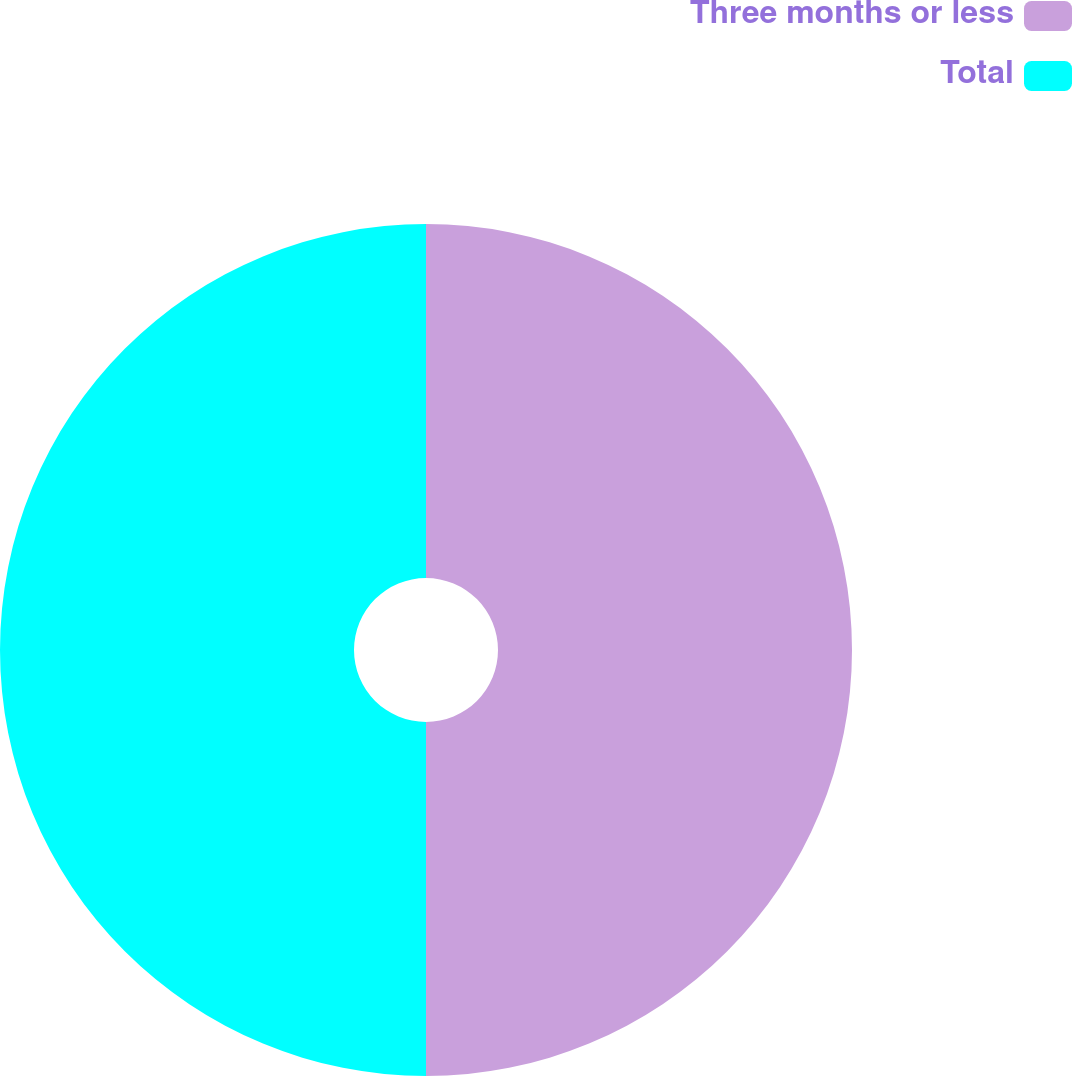Convert chart. <chart><loc_0><loc_0><loc_500><loc_500><pie_chart><fcel>Three months or less<fcel>Total<nl><fcel>50.0%<fcel>50.0%<nl></chart> 